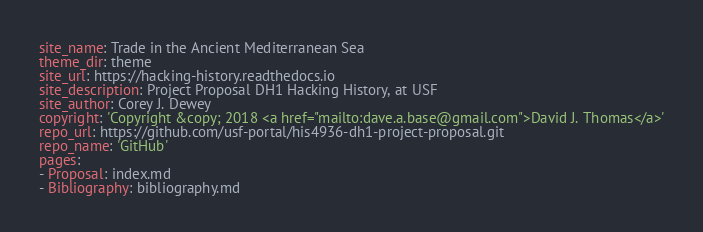Convert code to text. <code><loc_0><loc_0><loc_500><loc_500><_YAML_>site_name: Trade in the Ancient Mediterranean Sea
theme_dir: theme
site_url: https://hacking-history.readthedocs.io
site_description: Project Proposal DH1 Hacking History, at USF
site_author: Corey J. Dewey
copyright: 'Copyright &copy; 2018 <a href="mailto:dave.a.base@gmail.com">David J. Thomas</a>'
repo_url: https://github.com/usf-portal/his4936-dh1-project-proposal.git
repo_name: 'GitHub'
pages:
- Proposal: index.md
- Bibliography: bibliography.md
</code> 